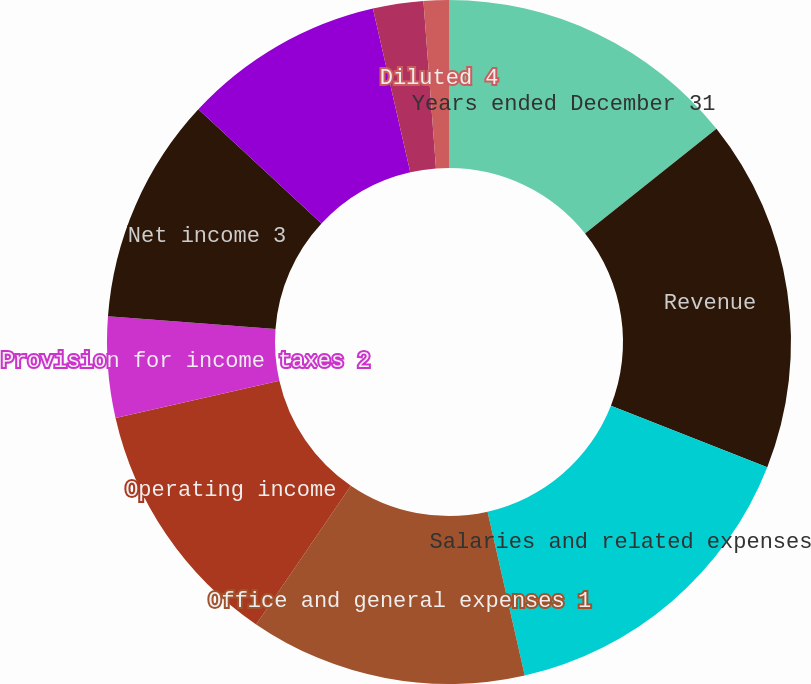<chart> <loc_0><loc_0><loc_500><loc_500><pie_chart><fcel>Years ended December 31<fcel>Revenue<fcel>Salaries and related expenses<fcel>Office and general expenses 1<fcel>Operating income<fcel>Provision for income taxes 2<fcel>Net income 3<fcel>Net income available to IPG<fcel>Basic 4<fcel>Diluted 4<nl><fcel>14.29%<fcel>16.67%<fcel>15.48%<fcel>13.09%<fcel>11.9%<fcel>4.76%<fcel>10.71%<fcel>9.52%<fcel>2.38%<fcel>1.19%<nl></chart> 